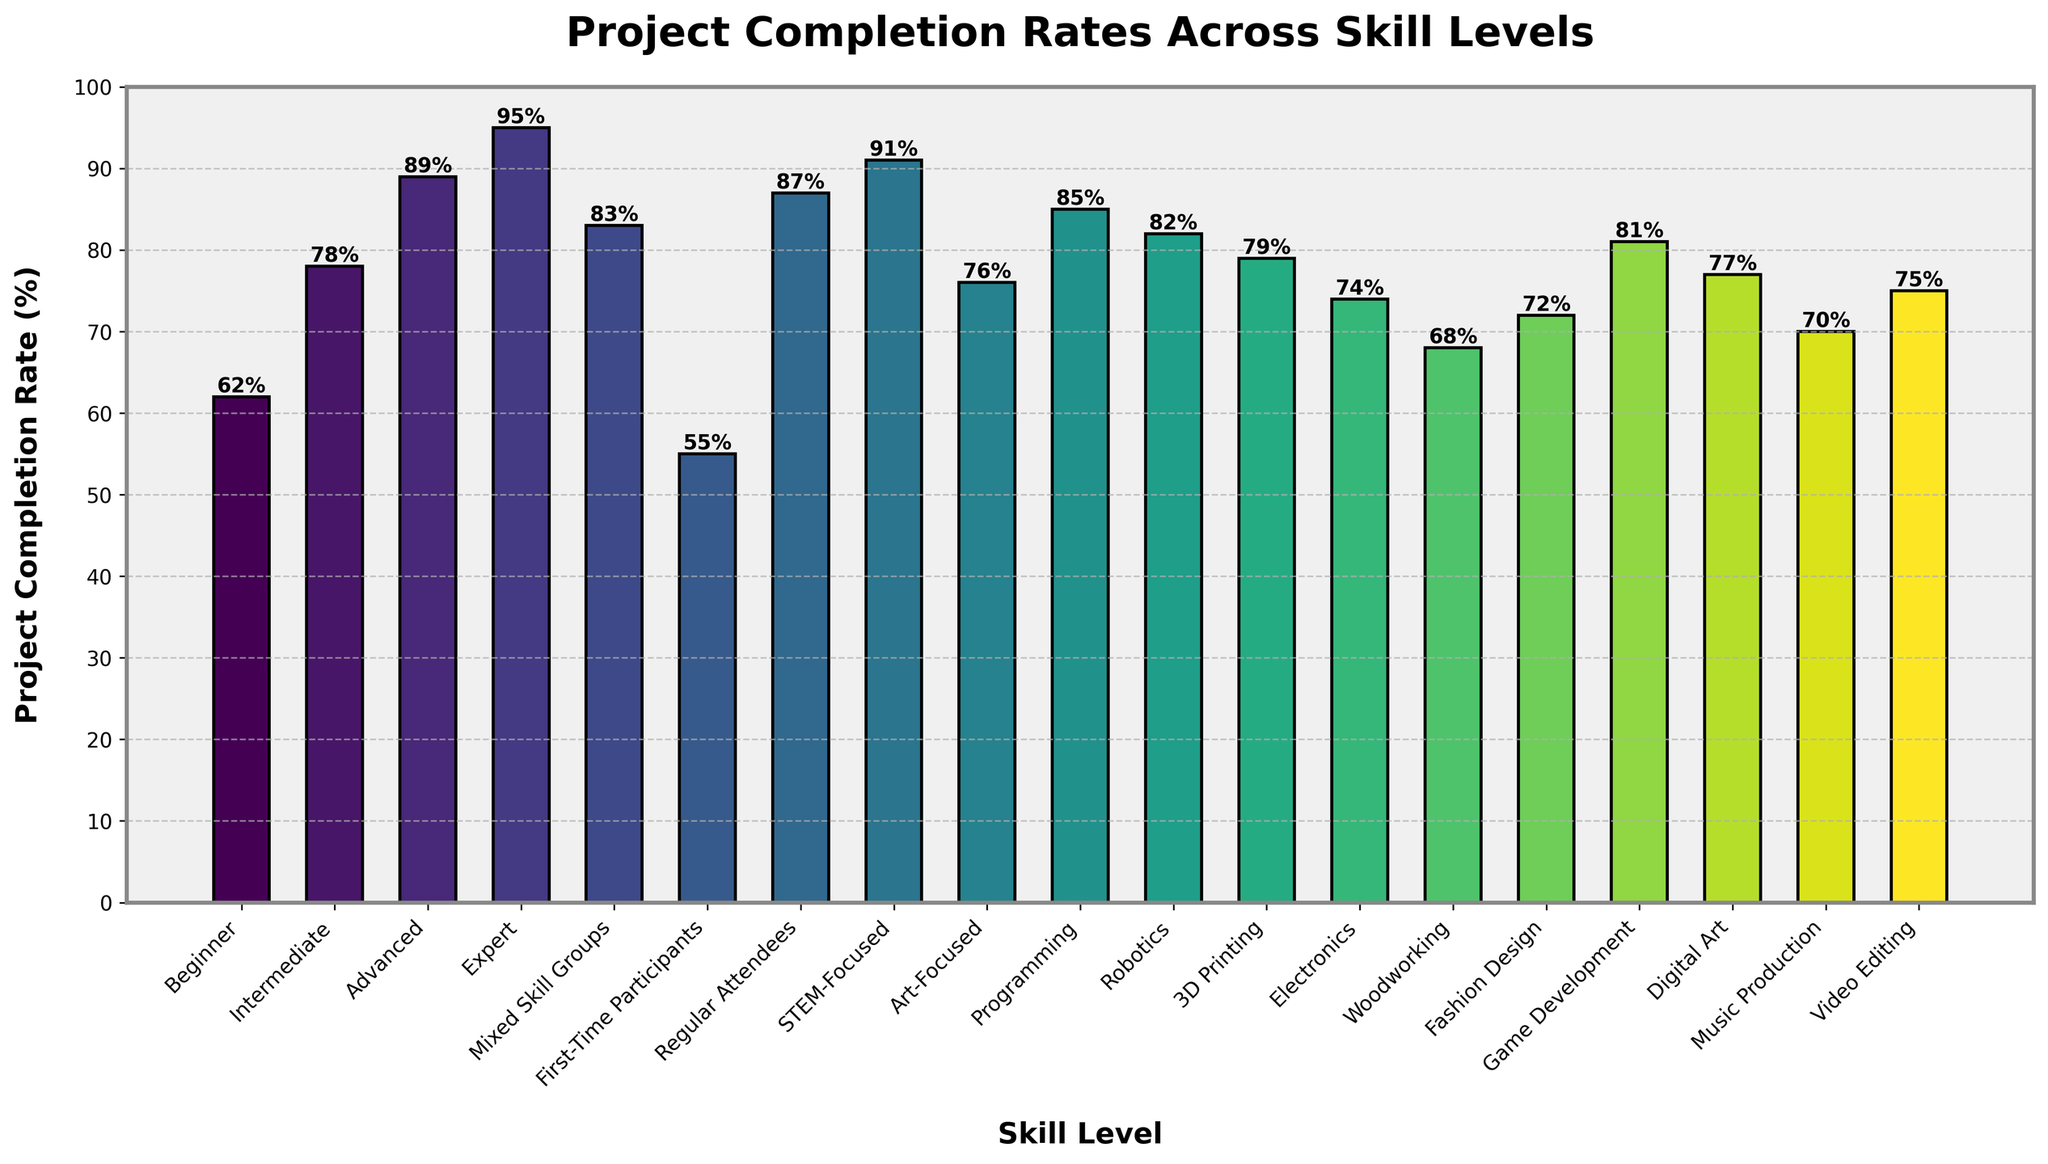What is the project completion rate for the "Expert" skill level? To find this, simply look for the bar labeled "Expert" on the x-axis and check its corresponding height. The label on top of the bar shows the percentage.
Answer: 95% What is the difference in project completion rates between "First-Time Participants" and "Regular Attendees"? Check the heights of the bars labeled "First-Time Participants" and "Regular Attendees". Subtract the lower percentage (55%) from the higher percentage (87%) to find the difference.
Answer: 32% Which skill level has the highest project completion rate? Identify the bar with the greatest height among all the bars. The label on top will show the completion rate. In this case, it is the "Expert" level.
Answer: Expert What's the average project completion rate for "Beginner", "Intermediate", and "Advanced" skill levels? First, find the completion rates for each of these skill levels (62%, 78%, and 89%). Sum them up (62 + 78 + 89 = 229) and divide by the number of skill levels (3).
Answer: 76.33% Is the project completion rate for "Art-Focused" higher than "Programming"? Compare the heights of the bars labeled "Art-Focused" and "Programming". "Programming" is higher with a completion rate of 85%, whereas "Art-Focused" has 76%.
Answer: No Which skill level has the lowest project completion rate? Identify the smallest bar among all the bars. The label on top will show the completion rate. In this case, it is "First-Time Participants".
Answer: First-Time Participants By how much does the "Mixed Skill Groups" completion rate exceed that of "Woodworking"? Find the rates for "Mixed Skill Groups" and "Woodworking" (83% and 68%, respectively). Subtract the lower rate from the higher rate (83 - 68).
Answer: 15% What percentage of the listed skill levels have a project completion rate above 80%? Count the number of skill levels with a rate above 80% (Intermediate, Advanced, Expert, Mixed Skill Groups, Regular Attendees, STEM-Focused, Programming, Robotics, Game Development). Divide this count (9) by the total number of skill levels (20) and multiply by 100.
Answer: 45% Is the completion rate for "Video Editing" taller than the average rate for all skill levels? First, calculate the average rate for all skill levels by summing (62 + 78 + 89 + 95 + 83 + 55 + 87 + 91 + 76 + 85 + 82 + 79 + 74 + 68 + 72 + 81 + 77 + 70 + 75) = 1478, and then divide by 19 (total categories) to get around 77.789%. Then compare "Video Editing" (75%) to this average.
Answer: No By what percentage is "STEM-Focused" higher than "Digital Art"? Find the completion rates for "STEM-Focused" (91%) and "Digital Art" (77%). Subtract 77 from 91 and divide by 77, then multiply by 100: ((91-77)/77) * 100.
Answer: 18.18% 